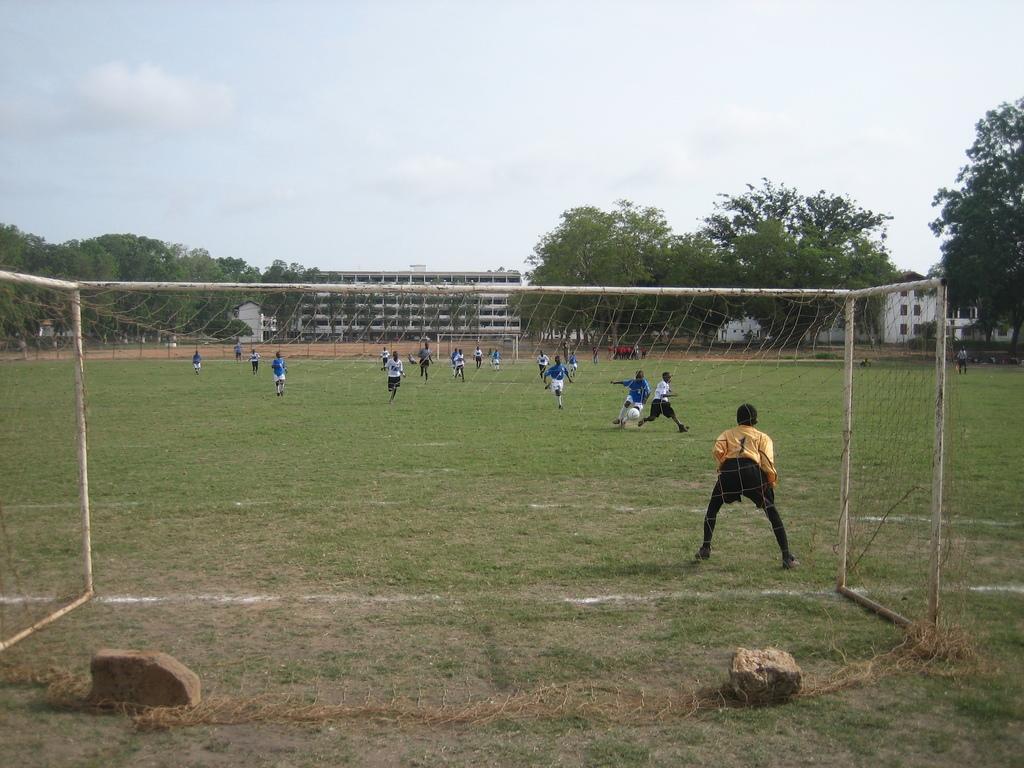How would you summarize this image in a sentence or two? In this image we can see some players on the ground. And we can see the net. And we can see the buildings, trees. And we can see the stones. And we can see the sky at the top. 